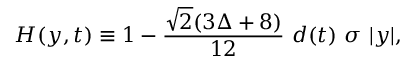Convert formula to latex. <formula><loc_0><loc_0><loc_500><loc_500>H ( y , t ) \equiv 1 - \frac { \sqrt { 2 } ( 3 \Delta + 8 ) } { 1 2 } \ d ( t ) \ \sigma \ | y | ,</formula> 